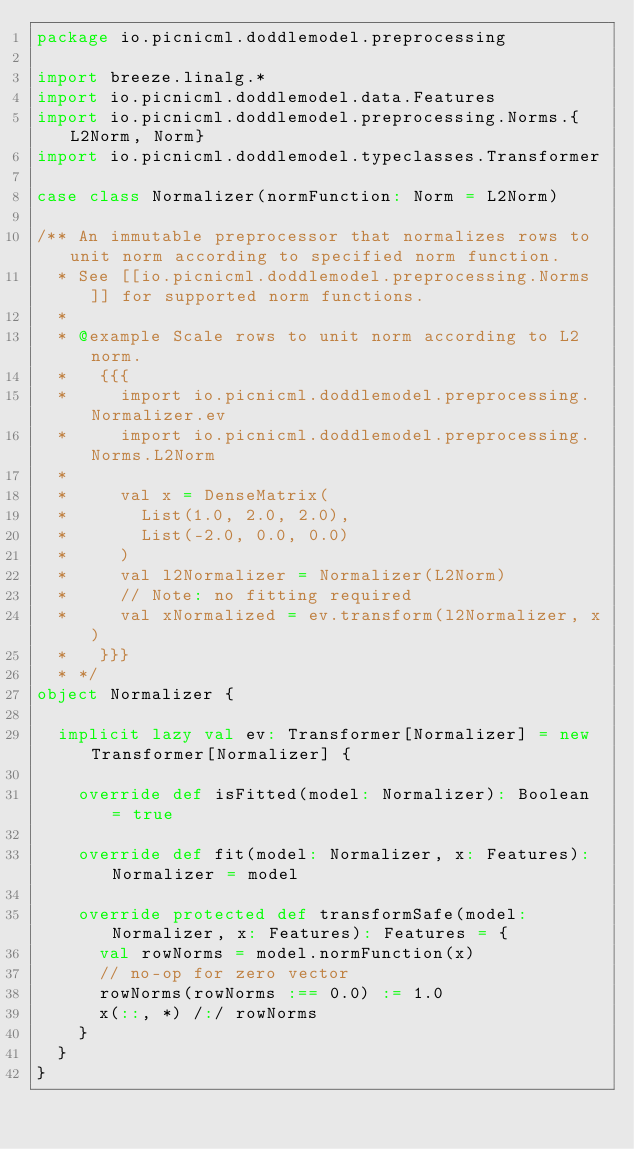<code> <loc_0><loc_0><loc_500><loc_500><_Scala_>package io.picnicml.doddlemodel.preprocessing

import breeze.linalg.*
import io.picnicml.doddlemodel.data.Features
import io.picnicml.doddlemodel.preprocessing.Norms.{L2Norm, Norm}
import io.picnicml.doddlemodel.typeclasses.Transformer

case class Normalizer(normFunction: Norm = L2Norm)

/** An immutable preprocessor that normalizes rows to unit norm according to specified norm function.
  * See [[io.picnicml.doddlemodel.preprocessing.Norms]] for supported norm functions.
  *
  * @example Scale rows to unit norm according to L2 norm.
  *   {{{
  *     import io.picnicml.doddlemodel.preprocessing.Normalizer.ev
  *     import io.picnicml.doddlemodel.preprocessing.Norms.L2Norm
  *
  *     val x = DenseMatrix(
  *       List(1.0, 2.0, 2.0),
  *       List(-2.0, 0.0, 0.0)
  *     )
  *     val l2Normalizer = Normalizer(L2Norm)
  *     // Note: no fitting required
  *     val xNormalized = ev.transform(l2Normalizer, x)
  *   }}}
  * */
object Normalizer {

  implicit lazy val ev: Transformer[Normalizer] = new Transformer[Normalizer] {

    override def isFitted(model: Normalizer): Boolean = true

    override def fit(model: Normalizer, x: Features): Normalizer = model

    override protected def transformSafe(model: Normalizer, x: Features): Features = {
      val rowNorms = model.normFunction(x)
      // no-op for zero vector
      rowNorms(rowNorms :== 0.0) := 1.0
      x(::, *) /:/ rowNorms
    }
  }
}
</code> 